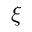Convert formula to latex. <formula><loc_0><loc_0><loc_500><loc_500>\xi</formula> 